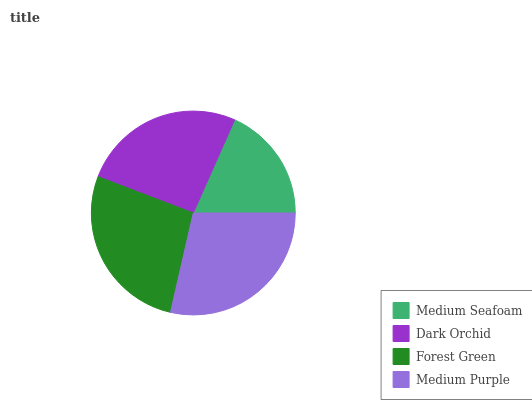Is Medium Seafoam the minimum?
Answer yes or no. Yes. Is Medium Purple the maximum?
Answer yes or no. Yes. Is Dark Orchid the minimum?
Answer yes or no. No. Is Dark Orchid the maximum?
Answer yes or no. No. Is Dark Orchid greater than Medium Seafoam?
Answer yes or no. Yes. Is Medium Seafoam less than Dark Orchid?
Answer yes or no. Yes. Is Medium Seafoam greater than Dark Orchid?
Answer yes or no. No. Is Dark Orchid less than Medium Seafoam?
Answer yes or no. No. Is Forest Green the high median?
Answer yes or no. Yes. Is Dark Orchid the low median?
Answer yes or no. Yes. Is Medium Seafoam the high median?
Answer yes or no. No. Is Medium Purple the low median?
Answer yes or no. No. 